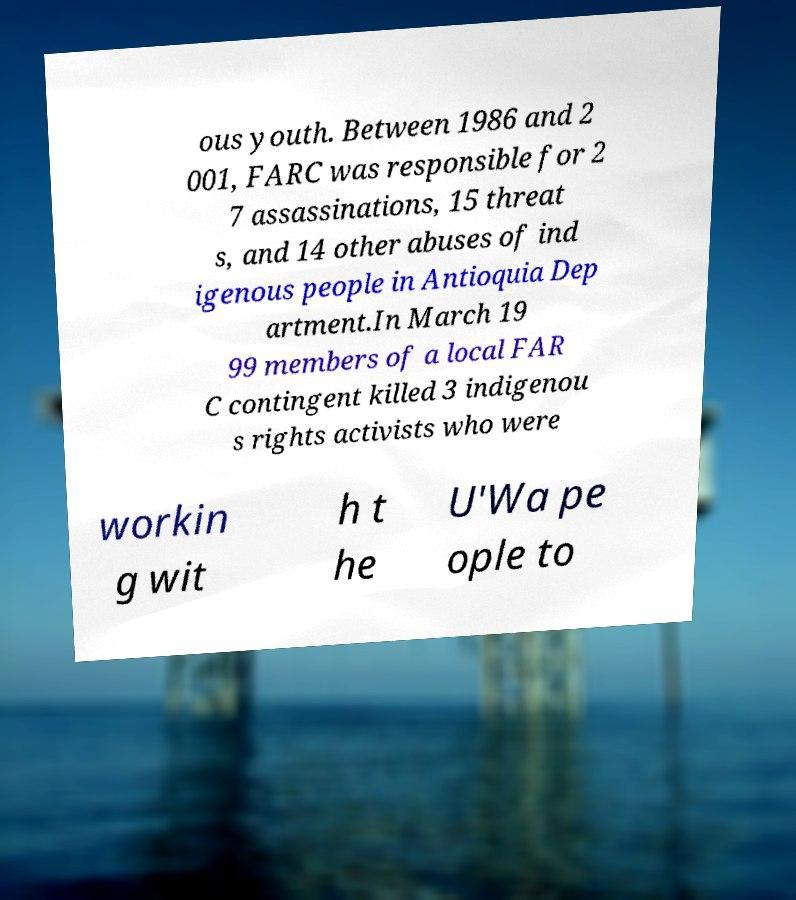Can you accurately transcribe the text from the provided image for me? ous youth. Between 1986 and 2 001, FARC was responsible for 2 7 assassinations, 15 threat s, and 14 other abuses of ind igenous people in Antioquia Dep artment.In March 19 99 members of a local FAR C contingent killed 3 indigenou s rights activists who were workin g wit h t he U'Wa pe ople to 